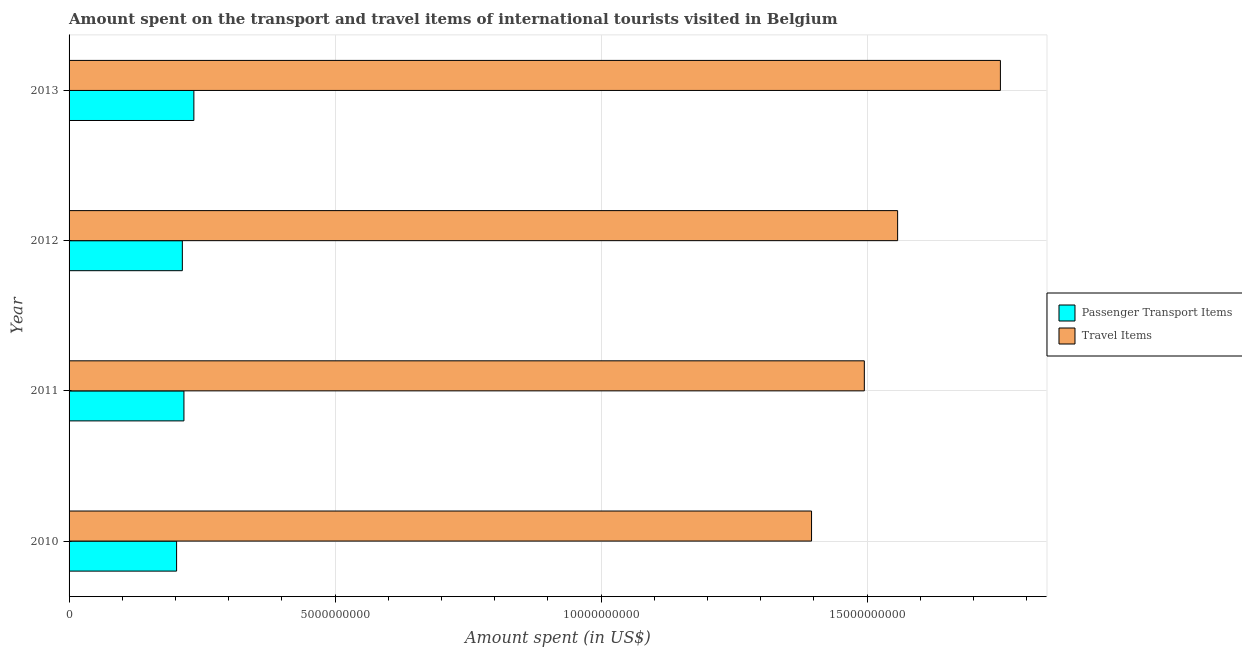Are the number of bars per tick equal to the number of legend labels?
Your response must be concise. Yes. How many bars are there on the 1st tick from the top?
Ensure brevity in your answer.  2. What is the amount spent on passenger transport items in 2010?
Your response must be concise. 2.02e+09. Across all years, what is the maximum amount spent in travel items?
Keep it short and to the point. 1.75e+1. Across all years, what is the minimum amount spent in travel items?
Your answer should be very brief. 1.40e+1. What is the total amount spent on passenger transport items in the graph?
Your response must be concise. 8.66e+09. What is the difference between the amount spent in travel items in 2010 and that in 2011?
Give a very brief answer. -9.92e+08. What is the difference between the amount spent in travel items in 2011 and the amount spent on passenger transport items in 2010?
Your response must be concise. 1.29e+1. What is the average amount spent in travel items per year?
Your answer should be very brief. 1.55e+1. In the year 2012, what is the difference between the amount spent on passenger transport items and amount spent in travel items?
Offer a terse response. -1.34e+1. What is the ratio of the amount spent on passenger transport items in 2012 to that in 2013?
Your response must be concise. 0.91. Is the amount spent on passenger transport items in 2012 less than that in 2013?
Keep it short and to the point. Yes. Is the difference between the amount spent on passenger transport items in 2011 and 2012 greater than the difference between the amount spent in travel items in 2011 and 2012?
Offer a very short reply. Yes. What is the difference between the highest and the second highest amount spent on passenger transport items?
Give a very brief answer. 1.87e+08. What is the difference between the highest and the lowest amount spent on passenger transport items?
Your answer should be compact. 3.25e+08. In how many years, is the amount spent on passenger transport items greater than the average amount spent on passenger transport items taken over all years?
Provide a short and direct response. 1. What does the 1st bar from the top in 2012 represents?
Offer a terse response. Travel Items. What does the 1st bar from the bottom in 2013 represents?
Your response must be concise. Passenger Transport Items. How many bars are there?
Make the answer very short. 8. Are all the bars in the graph horizontal?
Your answer should be compact. Yes. How many years are there in the graph?
Provide a succinct answer. 4. What is the difference between two consecutive major ticks on the X-axis?
Provide a short and direct response. 5.00e+09. Are the values on the major ticks of X-axis written in scientific E-notation?
Provide a succinct answer. No. Does the graph contain grids?
Provide a succinct answer. Yes. How many legend labels are there?
Your answer should be compact. 2. How are the legend labels stacked?
Provide a succinct answer. Vertical. What is the title of the graph?
Your answer should be compact. Amount spent on the transport and travel items of international tourists visited in Belgium. Does "Primary completion rate" appear as one of the legend labels in the graph?
Your answer should be very brief. No. What is the label or title of the X-axis?
Ensure brevity in your answer.  Amount spent (in US$). What is the label or title of the Y-axis?
Offer a very short reply. Year. What is the Amount spent (in US$) of Passenger Transport Items in 2010?
Offer a very short reply. 2.02e+09. What is the Amount spent (in US$) in Travel Items in 2010?
Offer a very short reply. 1.40e+1. What is the Amount spent (in US$) in Passenger Transport Items in 2011?
Provide a short and direct response. 2.16e+09. What is the Amount spent (in US$) in Travel Items in 2011?
Ensure brevity in your answer.  1.49e+1. What is the Amount spent (in US$) in Passenger Transport Items in 2012?
Offer a terse response. 2.13e+09. What is the Amount spent (in US$) of Travel Items in 2012?
Provide a short and direct response. 1.56e+1. What is the Amount spent (in US$) of Passenger Transport Items in 2013?
Keep it short and to the point. 2.35e+09. What is the Amount spent (in US$) in Travel Items in 2013?
Ensure brevity in your answer.  1.75e+1. Across all years, what is the maximum Amount spent (in US$) of Passenger Transport Items?
Keep it short and to the point. 2.35e+09. Across all years, what is the maximum Amount spent (in US$) in Travel Items?
Keep it short and to the point. 1.75e+1. Across all years, what is the minimum Amount spent (in US$) in Passenger Transport Items?
Provide a succinct answer. 2.02e+09. Across all years, what is the minimum Amount spent (in US$) in Travel Items?
Keep it short and to the point. 1.40e+1. What is the total Amount spent (in US$) of Passenger Transport Items in the graph?
Your answer should be very brief. 8.66e+09. What is the total Amount spent (in US$) of Travel Items in the graph?
Keep it short and to the point. 6.20e+1. What is the difference between the Amount spent (in US$) in Passenger Transport Items in 2010 and that in 2011?
Provide a short and direct response. -1.38e+08. What is the difference between the Amount spent (in US$) in Travel Items in 2010 and that in 2011?
Offer a terse response. -9.92e+08. What is the difference between the Amount spent (in US$) of Passenger Transport Items in 2010 and that in 2012?
Provide a short and direct response. -1.08e+08. What is the difference between the Amount spent (in US$) of Travel Items in 2010 and that in 2012?
Make the answer very short. -1.62e+09. What is the difference between the Amount spent (in US$) in Passenger Transport Items in 2010 and that in 2013?
Your answer should be very brief. -3.25e+08. What is the difference between the Amount spent (in US$) of Travel Items in 2010 and that in 2013?
Make the answer very short. -3.55e+09. What is the difference between the Amount spent (in US$) of Passenger Transport Items in 2011 and that in 2012?
Provide a short and direct response. 3.00e+07. What is the difference between the Amount spent (in US$) of Travel Items in 2011 and that in 2012?
Keep it short and to the point. -6.26e+08. What is the difference between the Amount spent (in US$) of Passenger Transport Items in 2011 and that in 2013?
Ensure brevity in your answer.  -1.87e+08. What is the difference between the Amount spent (in US$) in Travel Items in 2011 and that in 2013?
Provide a short and direct response. -2.56e+09. What is the difference between the Amount spent (in US$) in Passenger Transport Items in 2012 and that in 2013?
Provide a succinct answer. -2.17e+08. What is the difference between the Amount spent (in US$) of Travel Items in 2012 and that in 2013?
Your answer should be very brief. -1.93e+09. What is the difference between the Amount spent (in US$) in Passenger Transport Items in 2010 and the Amount spent (in US$) in Travel Items in 2011?
Offer a terse response. -1.29e+1. What is the difference between the Amount spent (in US$) in Passenger Transport Items in 2010 and the Amount spent (in US$) in Travel Items in 2012?
Offer a terse response. -1.36e+1. What is the difference between the Amount spent (in US$) of Passenger Transport Items in 2010 and the Amount spent (in US$) of Travel Items in 2013?
Provide a succinct answer. -1.55e+1. What is the difference between the Amount spent (in US$) of Passenger Transport Items in 2011 and the Amount spent (in US$) of Travel Items in 2012?
Offer a terse response. -1.34e+1. What is the difference between the Amount spent (in US$) in Passenger Transport Items in 2011 and the Amount spent (in US$) in Travel Items in 2013?
Your response must be concise. -1.53e+1. What is the difference between the Amount spent (in US$) of Passenger Transport Items in 2012 and the Amount spent (in US$) of Travel Items in 2013?
Provide a succinct answer. -1.54e+1. What is the average Amount spent (in US$) of Passenger Transport Items per year?
Your answer should be very brief. 2.16e+09. What is the average Amount spent (in US$) of Travel Items per year?
Ensure brevity in your answer.  1.55e+1. In the year 2010, what is the difference between the Amount spent (in US$) of Passenger Transport Items and Amount spent (in US$) of Travel Items?
Give a very brief answer. -1.19e+1. In the year 2011, what is the difference between the Amount spent (in US$) of Passenger Transport Items and Amount spent (in US$) of Travel Items?
Provide a short and direct response. -1.28e+1. In the year 2012, what is the difference between the Amount spent (in US$) in Passenger Transport Items and Amount spent (in US$) in Travel Items?
Your answer should be compact. -1.34e+1. In the year 2013, what is the difference between the Amount spent (in US$) in Passenger Transport Items and Amount spent (in US$) in Travel Items?
Give a very brief answer. -1.52e+1. What is the ratio of the Amount spent (in US$) in Passenger Transport Items in 2010 to that in 2011?
Your answer should be compact. 0.94. What is the ratio of the Amount spent (in US$) in Travel Items in 2010 to that in 2011?
Give a very brief answer. 0.93. What is the ratio of the Amount spent (in US$) in Passenger Transport Items in 2010 to that in 2012?
Your answer should be very brief. 0.95. What is the ratio of the Amount spent (in US$) in Travel Items in 2010 to that in 2012?
Offer a very short reply. 0.9. What is the ratio of the Amount spent (in US$) of Passenger Transport Items in 2010 to that in 2013?
Offer a very short reply. 0.86. What is the ratio of the Amount spent (in US$) in Travel Items in 2010 to that in 2013?
Provide a succinct answer. 0.8. What is the ratio of the Amount spent (in US$) of Passenger Transport Items in 2011 to that in 2012?
Your answer should be compact. 1.01. What is the ratio of the Amount spent (in US$) of Travel Items in 2011 to that in 2012?
Give a very brief answer. 0.96. What is the ratio of the Amount spent (in US$) in Passenger Transport Items in 2011 to that in 2013?
Provide a succinct answer. 0.92. What is the ratio of the Amount spent (in US$) of Travel Items in 2011 to that in 2013?
Your answer should be compact. 0.85. What is the ratio of the Amount spent (in US$) in Passenger Transport Items in 2012 to that in 2013?
Your answer should be very brief. 0.91. What is the ratio of the Amount spent (in US$) in Travel Items in 2012 to that in 2013?
Provide a succinct answer. 0.89. What is the difference between the highest and the second highest Amount spent (in US$) of Passenger Transport Items?
Give a very brief answer. 1.87e+08. What is the difference between the highest and the second highest Amount spent (in US$) in Travel Items?
Your response must be concise. 1.93e+09. What is the difference between the highest and the lowest Amount spent (in US$) in Passenger Transport Items?
Your response must be concise. 3.25e+08. What is the difference between the highest and the lowest Amount spent (in US$) of Travel Items?
Provide a succinct answer. 3.55e+09. 